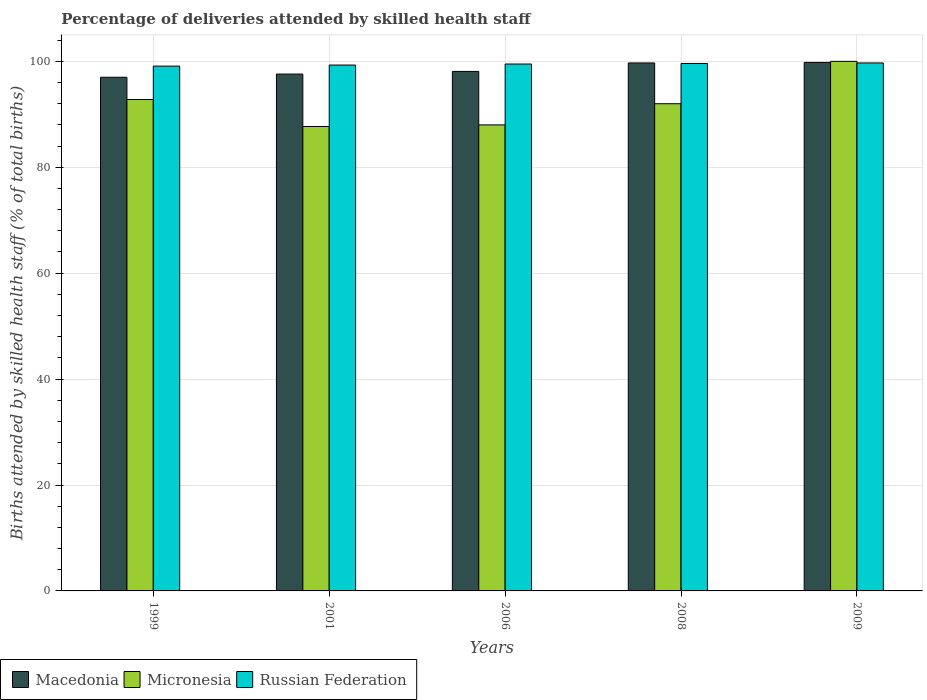How many different coloured bars are there?
Your answer should be very brief. 3. Are the number of bars per tick equal to the number of legend labels?
Keep it short and to the point. Yes. Are the number of bars on each tick of the X-axis equal?
Your answer should be very brief. Yes. How many bars are there on the 2nd tick from the right?
Your response must be concise. 3. What is the label of the 2nd group of bars from the left?
Your answer should be very brief. 2001. What is the percentage of births attended by skilled health staff in Russian Federation in 2008?
Keep it short and to the point. 99.6. Across all years, what is the maximum percentage of births attended by skilled health staff in Macedonia?
Provide a succinct answer. 99.8. Across all years, what is the minimum percentage of births attended by skilled health staff in Micronesia?
Ensure brevity in your answer.  87.7. In which year was the percentage of births attended by skilled health staff in Russian Federation maximum?
Your response must be concise. 2009. In which year was the percentage of births attended by skilled health staff in Micronesia minimum?
Keep it short and to the point. 2001. What is the total percentage of births attended by skilled health staff in Micronesia in the graph?
Offer a terse response. 460.5. What is the difference between the percentage of births attended by skilled health staff in Micronesia in 1999 and that in 2001?
Offer a terse response. 5.1. What is the difference between the percentage of births attended by skilled health staff in Russian Federation in 2008 and the percentage of births attended by skilled health staff in Macedonia in 2009?
Your answer should be very brief. -0.2. What is the average percentage of births attended by skilled health staff in Macedonia per year?
Offer a terse response. 98.44. In the year 2008, what is the difference between the percentage of births attended by skilled health staff in Micronesia and percentage of births attended by skilled health staff in Macedonia?
Offer a terse response. -7.7. What is the ratio of the percentage of births attended by skilled health staff in Macedonia in 1999 to that in 2001?
Offer a terse response. 0.99. Is the percentage of births attended by skilled health staff in Micronesia in 2001 less than that in 2008?
Ensure brevity in your answer.  Yes. Is the difference between the percentage of births attended by skilled health staff in Micronesia in 2008 and 2009 greater than the difference between the percentage of births attended by skilled health staff in Macedonia in 2008 and 2009?
Your answer should be very brief. No. What is the difference between the highest and the second highest percentage of births attended by skilled health staff in Russian Federation?
Give a very brief answer. 0.1. What is the difference between the highest and the lowest percentage of births attended by skilled health staff in Macedonia?
Give a very brief answer. 2.8. In how many years, is the percentage of births attended by skilled health staff in Macedonia greater than the average percentage of births attended by skilled health staff in Macedonia taken over all years?
Your answer should be very brief. 2. Is the sum of the percentage of births attended by skilled health staff in Micronesia in 1999 and 2008 greater than the maximum percentage of births attended by skilled health staff in Russian Federation across all years?
Your answer should be very brief. Yes. What does the 1st bar from the left in 2008 represents?
Make the answer very short. Macedonia. What does the 3rd bar from the right in 1999 represents?
Ensure brevity in your answer.  Macedonia. Is it the case that in every year, the sum of the percentage of births attended by skilled health staff in Micronesia and percentage of births attended by skilled health staff in Russian Federation is greater than the percentage of births attended by skilled health staff in Macedonia?
Your answer should be compact. Yes. Are all the bars in the graph horizontal?
Your answer should be compact. No. Are the values on the major ticks of Y-axis written in scientific E-notation?
Provide a succinct answer. No. Does the graph contain grids?
Make the answer very short. Yes. What is the title of the graph?
Provide a succinct answer. Percentage of deliveries attended by skilled health staff. What is the label or title of the X-axis?
Provide a succinct answer. Years. What is the label or title of the Y-axis?
Provide a succinct answer. Births attended by skilled health staff (% of total births). What is the Births attended by skilled health staff (% of total births) of Macedonia in 1999?
Provide a short and direct response. 97. What is the Births attended by skilled health staff (% of total births) in Micronesia in 1999?
Keep it short and to the point. 92.8. What is the Births attended by skilled health staff (% of total births) in Russian Federation in 1999?
Provide a succinct answer. 99.1. What is the Births attended by skilled health staff (% of total births) in Macedonia in 2001?
Offer a very short reply. 97.6. What is the Births attended by skilled health staff (% of total births) of Micronesia in 2001?
Ensure brevity in your answer.  87.7. What is the Births attended by skilled health staff (% of total births) of Russian Federation in 2001?
Keep it short and to the point. 99.3. What is the Births attended by skilled health staff (% of total births) in Macedonia in 2006?
Keep it short and to the point. 98.1. What is the Births attended by skilled health staff (% of total births) of Micronesia in 2006?
Your answer should be very brief. 88. What is the Births attended by skilled health staff (% of total births) in Russian Federation in 2006?
Make the answer very short. 99.5. What is the Births attended by skilled health staff (% of total births) of Macedonia in 2008?
Your answer should be very brief. 99.7. What is the Births attended by skilled health staff (% of total births) of Micronesia in 2008?
Provide a short and direct response. 92. What is the Births attended by skilled health staff (% of total births) of Russian Federation in 2008?
Offer a very short reply. 99.6. What is the Births attended by skilled health staff (% of total births) in Macedonia in 2009?
Your response must be concise. 99.8. What is the Births attended by skilled health staff (% of total births) in Russian Federation in 2009?
Keep it short and to the point. 99.7. Across all years, what is the maximum Births attended by skilled health staff (% of total births) of Macedonia?
Offer a very short reply. 99.8. Across all years, what is the maximum Births attended by skilled health staff (% of total births) in Micronesia?
Ensure brevity in your answer.  100. Across all years, what is the maximum Births attended by skilled health staff (% of total births) in Russian Federation?
Your answer should be very brief. 99.7. Across all years, what is the minimum Births attended by skilled health staff (% of total births) of Macedonia?
Provide a short and direct response. 97. Across all years, what is the minimum Births attended by skilled health staff (% of total births) in Micronesia?
Your answer should be compact. 87.7. Across all years, what is the minimum Births attended by skilled health staff (% of total births) of Russian Federation?
Keep it short and to the point. 99.1. What is the total Births attended by skilled health staff (% of total births) in Macedonia in the graph?
Provide a succinct answer. 492.2. What is the total Births attended by skilled health staff (% of total births) of Micronesia in the graph?
Give a very brief answer. 460.5. What is the total Births attended by skilled health staff (% of total births) of Russian Federation in the graph?
Ensure brevity in your answer.  497.2. What is the difference between the Births attended by skilled health staff (% of total births) in Macedonia in 1999 and that in 2001?
Keep it short and to the point. -0.6. What is the difference between the Births attended by skilled health staff (% of total births) in Micronesia in 1999 and that in 2001?
Offer a very short reply. 5.1. What is the difference between the Births attended by skilled health staff (% of total births) of Russian Federation in 1999 and that in 2001?
Your answer should be compact. -0.2. What is the difference between the Births attended by skilled health staff (% of total births) in Micronesia in 1999 and that in 2008?
Provide a short and direct response. 0.8. What is the difference between the Births attended by skilled health staff (% of total births) of Russian Federation in 1999 and that in 2008?
Your response must be concise. -0.5. What is the difference between the Births attended by skilled health staff (% of total births) of Macedonia in 1999 and that in 2009?
Provide a short and direct response. -2.8. What is the difference between the Births attended by skilled health staff (% of total births) in Micronesia in 1999 and that in 2009?
Offer a terse response. -7.2. What is the difference between the Births attended by skilled health staff (% of total births) of Micronesia in 2001 and that in 2008?
Ensure brevity in your answer.  -4.3. What is the difference between the Births attended by skilled health staff (% of total births) in Micronesia in 2006 and that in 2008?
Offer a very short reply. -4. What is the difference between the Births attended by skilled health staff (% of total births) of Macedonia in 2006 and that in 2009?
Provide a short and direct response. -1.7. What is the difference between the Births attended by skilled health staff (% of total births) of Micronesia in 2006 and that in 2009?
Give a very brief answer. -12. What is the difference between the Births attended by skilled health staff (% of total births) in Macedonia in 2008 and that in 2009?
Your answer should be compact. -0.1. What is the difference between the Births attended by skilled health staff (% of total births) of Micronesia in 2008 and that in 2009?
Your response must be concise. -8. What is the difference between the Births attended by skilled health staff (% of total births) of Macedonia in 1999 and the Births attended by skilled health staff (% of total births) of Micronesia in 2006?
Give a very brief answer. 9. What is the difference between the Births attended by skilled health staff (% of total births) of Macedonia in 1999 and the Births attended by skilled health staff (% of total births) of Russian Federation in 2008?
Provide a succinct answer. -2.6. What is the difference between the Births attended by skilled health staff (% of total births) in Macedonia in 1999 and the Births attended by skilled health staff (% of total births) in Russian Federation in 2009?
Provide a succinct answer. -2.7. What is the difference between the Births attended by skilled health staff (% of total births) in Macedonia in 2001 and the Births attended by skilled health staff (% of total births) in Russian Federation in 2006?
Offer a terse response. -1.9. What is the difference between the Births attended by skilled health staff (% of total births) of Macedonia in 2001 and the Births attended by skilled health staff (% of total births) of Russian Federation in 2009?
Your response must be concise. -2.1. What is the difference between the Births attended by skilled health staff (% of total births) of Micronesia in 2001 and the Births attended by skilled health staff (% of total births) of Russian Federation in 2009?
Ensure brevity in your answer.  -12. What is the difference between the Births attended by skilled health staff (% of total births) of Macedonia in 2006 and the Births attended by skilled health staff (% of total births) of Russian Federation in 2008?
Offer a very short reply. -1.5. What is the difference between the Births attended by skilled health staff (% of total births) of Micronesia in 2006 and the Births attended by skilled health staff (% of total births) of Russian Federation in 2008?
Provide a short and direct response. -11.6. What is the difference between the Births attended by skilled health staff (% of total births) in Macedonia in 2006 and the Births attended by skilled health staff (% of total births) in Micronesia in 2009?
Make the answer very short. -1.9. What is the difference between the Births attended by skilled health staff (% of total births) of Macedonia in 2006 and the Births attended by skilled health staff (% of total births) of Russian Federation in 2009?
Provide a short and direct response. -1.6. What is the difference between the Births attended by skilled health staff (% of total births) in Macedonia in 2008 and the Births attended by skilled health staff (% of total births) in Micronesia in 2009?
Your response must be concise. -0.3. What is the average Births attended by skilled health staff (% of total births) of Macedonia per year?
Your answer should be very brief. 98.44. What is the average Births attended by skilled health staff (% of total births) in Micronesia per year?
Offer a terse response. 92.1. What is the average Births attended by skilled health staff (% of total births) of Russian Federation per year?
Your response must be concise. 99.44. In the year 1999, what is the difference between the Births attended by skilled health staff (% of total births) in Micronesia and Births attended by skilled health staff (% of total births) in Russian Federation?
Keep it short and to the point. -6.3. In the year 2001, what is the difference between the Births attended by skilled health staff (% of total births) of Macedonia and Births attended by skilled health staff (% of total births) of Micronesia?
Provide a short and direct response. 9.9. In the year 2001, what is the difference between the Births attended by skilled health staff (% of total births) of Macedonia and Births attended by skilled health staff (% of total births) of Russian Federation?
Provide a short and direct response. -1.7. In the year 2006, what is the difference between the Births attended by skilled health staff (% of total births) in Micronesia and Births attended by skilled health staff (% of total births) in Russian Federation?
Offer a very short reply. -11.5. In the year 2008, what is the difference between the Births attended by skilled health staff (% of total births) of Macedonia and Births attended by skilled health staff (% of total births) of Micronesia?
Your answer should be very brief. 7.7. In the year 2008, what is the difference between the Births attended by skilled health staff (% of total births) in Micronesia and Births attended by skilled health staff (% of total births) in Russian Federation?
Provide a succinct answer. -7.6. In the year 2009, what is the difference between the Births attended by skilled health staff (% of total births) in Macedonia and Births attended by skilled health staff (% of total births) in Russian Federation?
Offer a terse response. 0.1. What is the ratio of the Births attended by skilled health staff (% of total births) of Micronesia in 1999 to that in 2001?
Give a very brief answer. 1.06. What is the ratio of the Births attended by skilled health staff (% of total births) of Macedonia in 1999 to that in 2006?
Your answer should be very brief. 0.99. What is the ratio of the Births attended by skilled health staff (% of total births) of Micronesia in 1999 to that in 2006?
Make the answer very short. 1.05. What is the ratio of the Births attended by skilled health staff (% of total births) of Macedonia in 1999 to that in 2008?
Make the answer very short. 0.97. What is the ratio of the Births attended by skilled health staff (% of total births) in Micronesia in 1999 to that in 2008?
Keep it short and to the point. 1.01. What is the ratio of the Births attended by skilled health staff (% of total births) of Macedonia in 1999 to that in 2009?
Make the answer very short. 0.97. What is the ratio of the Births attended by skilled health staff (% of total births) in Micronesia in 1999 to that in 2009?
Provide a succinct answer. 0.93. What is the ratio of the Births attended by skilled health staff (% of total births) in Macedonia in 2001 to that in 2008?
Provide a short and direct response. 0.98. What is the ratio of the Births attended by skilled health staff (% of total births) of Micronesia in 2001 to that in 2008?
Provide a succinct answer. 0.95. What is the ratio of the Births attended by skilled health staff (% of total births) of Russian Federation in 2001 to that in 2008?
Keep it short and to the point. 1. What is the ratio of the Births attended by skilled health staff (% of total births) in Micronesia in 2001 to that in 2009?
Your response must be concise. 0.88. What is the ratio of the Births attended by skilled health staff (% of total births) of Micronesia in 2006 to that in 2008?
Provide a succinct answer. 0.96. What is the ratio of the Births attended by skilled health staff (% of total births) in Russian Federation in 2006 to that in 2008?
Make the answer very short. 1. What is the ratio of the Births attended by skilled health staff (% of total births) in Macedonia in 2008 to that in 2009?
Keep it short and to the point. 1. What is the ratio of the Births attended by skilled health staff (% of total births) in Micronesia in 2008 to that in 2009?
Provide a short and direct response. 0.92. What is the difference between the highest and the lowest Births attended by skilled health staff (% of total births) of Macedonia?
Provide a succinct answer. 2.8. What is the difference between the highest and the lowest Births attended by skilled health staff (% of total births) of Micronesia?
Offer a very short reply. 12.3. 